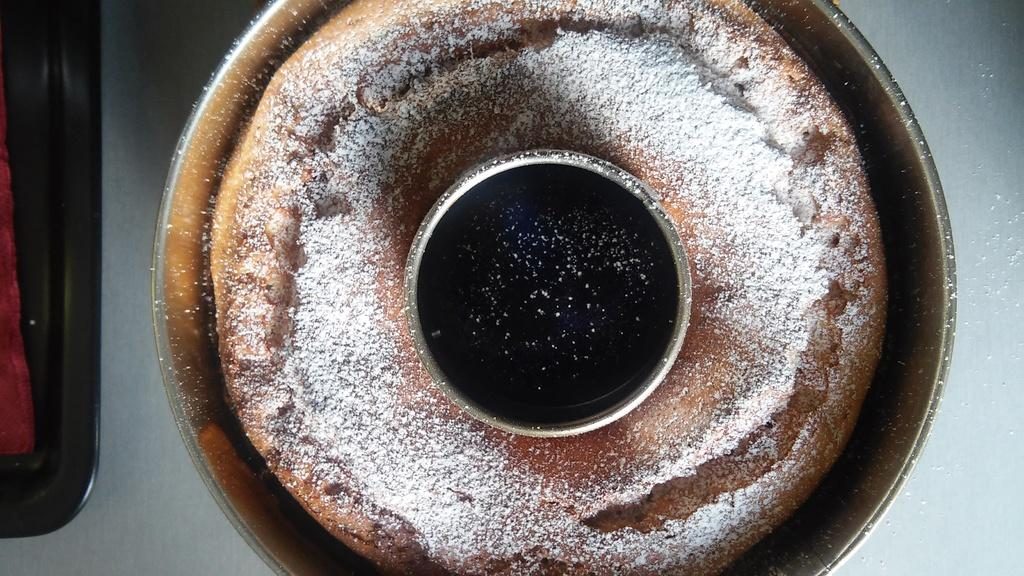What is the main subject of the image? There is a cake in the image. What type of experience does the crow have in managing the cake in the image? There is no crow or any indication of management in the image; it only features a cake. 